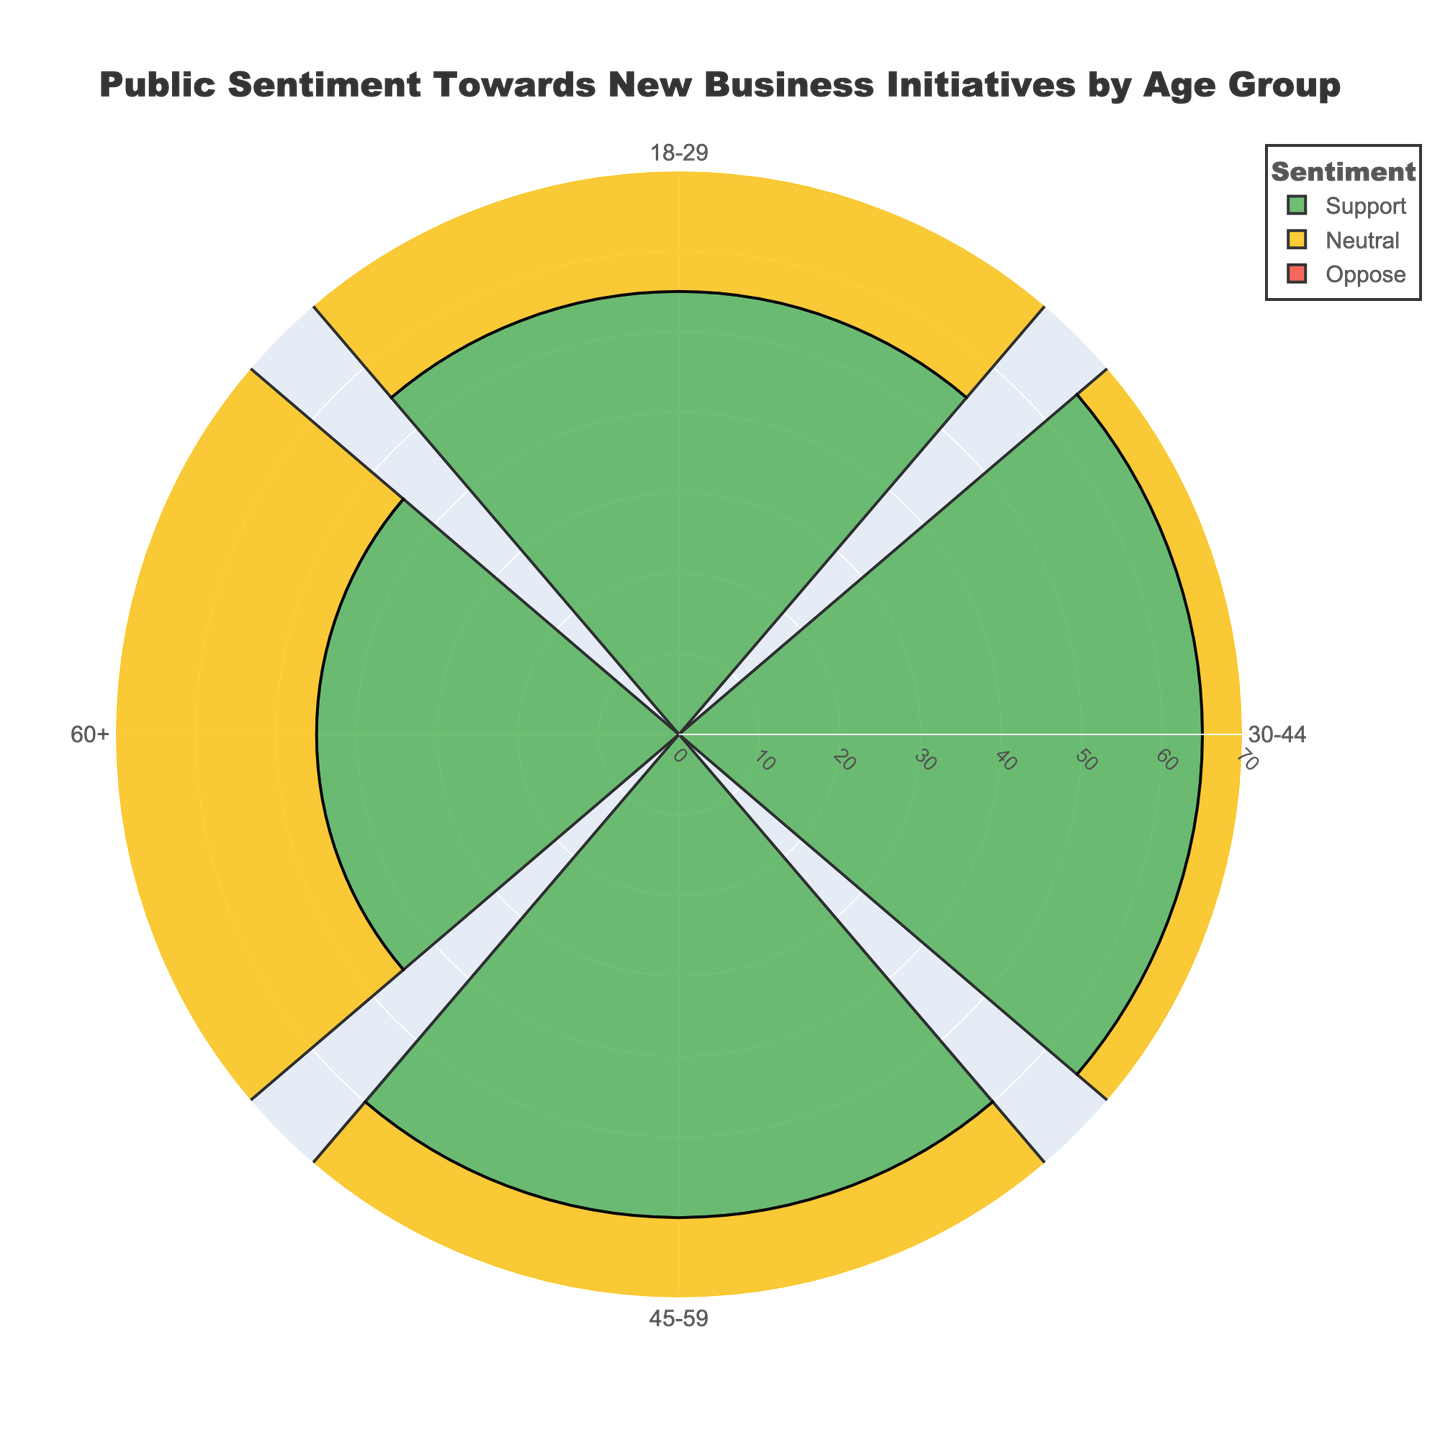What is the title of the chart? The title of the chart is shown prominently at the top.
Answer: Public Sentiment Towards New Business Initiatives by Age Group Which age group has the highest percentage of support? By observing the lengths of the 'Support' sections across different age groups, we can see which one extends the furthest from the center.
Answer: 30-44 Which sentiment category is represented by red? By examining the legend in the chart, we can see the color assignments for each sentiment.
Answer: Oppose How many age groups are displayed in the chart? The chart contains segments labeled with age groups around the polar axis.
Answer: 4 Which age group has the smallest percentage of neutral sentiment? By looking at the lengths of the 'Neutral' sections, we can identify the shortest one.
Answer: 30-44 Compare the support sentiment between the 18-29 and 60+ age groups. Which is higher? By comparing the lengths of the 'Support' sections for these two age groups, we can determine which one extends more.
Answer: 18-29 Calculate the average percentage of opposition across all age groups. First, sum the opposition percentages for all age groups (20 + 15 + 15 + 20 = 70). Then divide by 4 (since there are 4 age groups).
Answer: 17.5 What is the total percentage of neutral sentiment observed in the 45-59 age group? The value for the neutral category in this age group is given directly in the data displayed in the chart segments.
Answer: 25 Which age group's sentiment distribution is closest to being equally divided among the three categories? By comparing the lengths of the 'Support', 'Neutral', and 'Oppose' sections across all age groups, we see which divides closer to equal thirds.
Answer: 60+ In which age group is the difference between support and opposition the greatest? Calculate the difference for each age group: 
18-29 (55-20 = 35), 
30-44 (65-15 = 50), 
45-59 (60-15 = 45), 
60+ (45-20 = 25),
and identify the maximum difference.
Answer: 30-44 